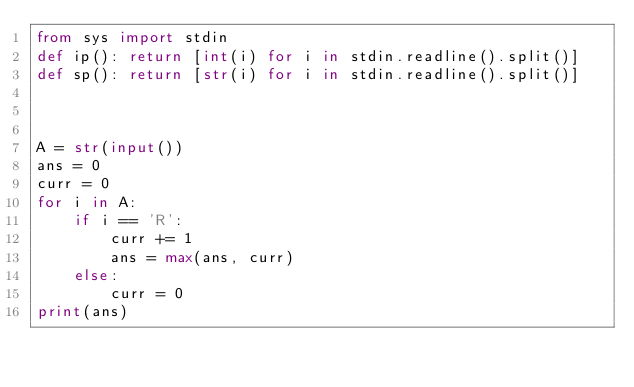Convert code to text. <code><loc_0><loc_0><loc_500><loc_500><_Python_>from sys import stdin
def ip(): return [int(i) for i in stdin.readline().split()]
def sp(): return [str(i) for i in stdin.readline().split()]



A = str(input())
ans = 0
curr = 0
for i in A:
    if i == 'R':
        curr += 1
        ans = max(ans, curr)
    else:
        curr = 0
print(ans)</code> 